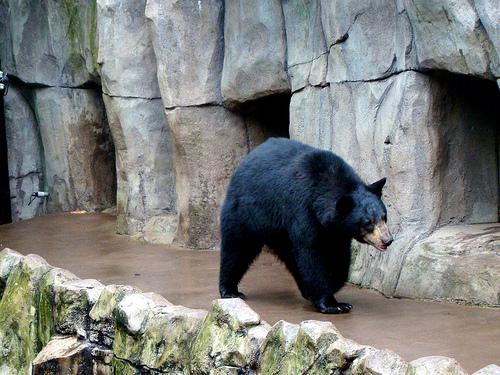Question: where was the photo taken?
Choices:
A. On an African safari.
B. At the zoo.
C. Sea World.
D. Out in the wild.
Answer with the letter. Answer: B Question: what is black?
Choices:
A. The bear.
B. The dog.
C. The car.
D. The tire.
Answer with the letter. Answer: A Question: how many bear are there?
Choices:
A. None.
B. Two.
C. Three.
D. One.
Answer with the letter. Answer: D Question: when was the photo taken?
Choices:
A. At dusk.
B. Day time.
C. Dawn.
D. Early morning.
Answer with the letter. Answer: B 